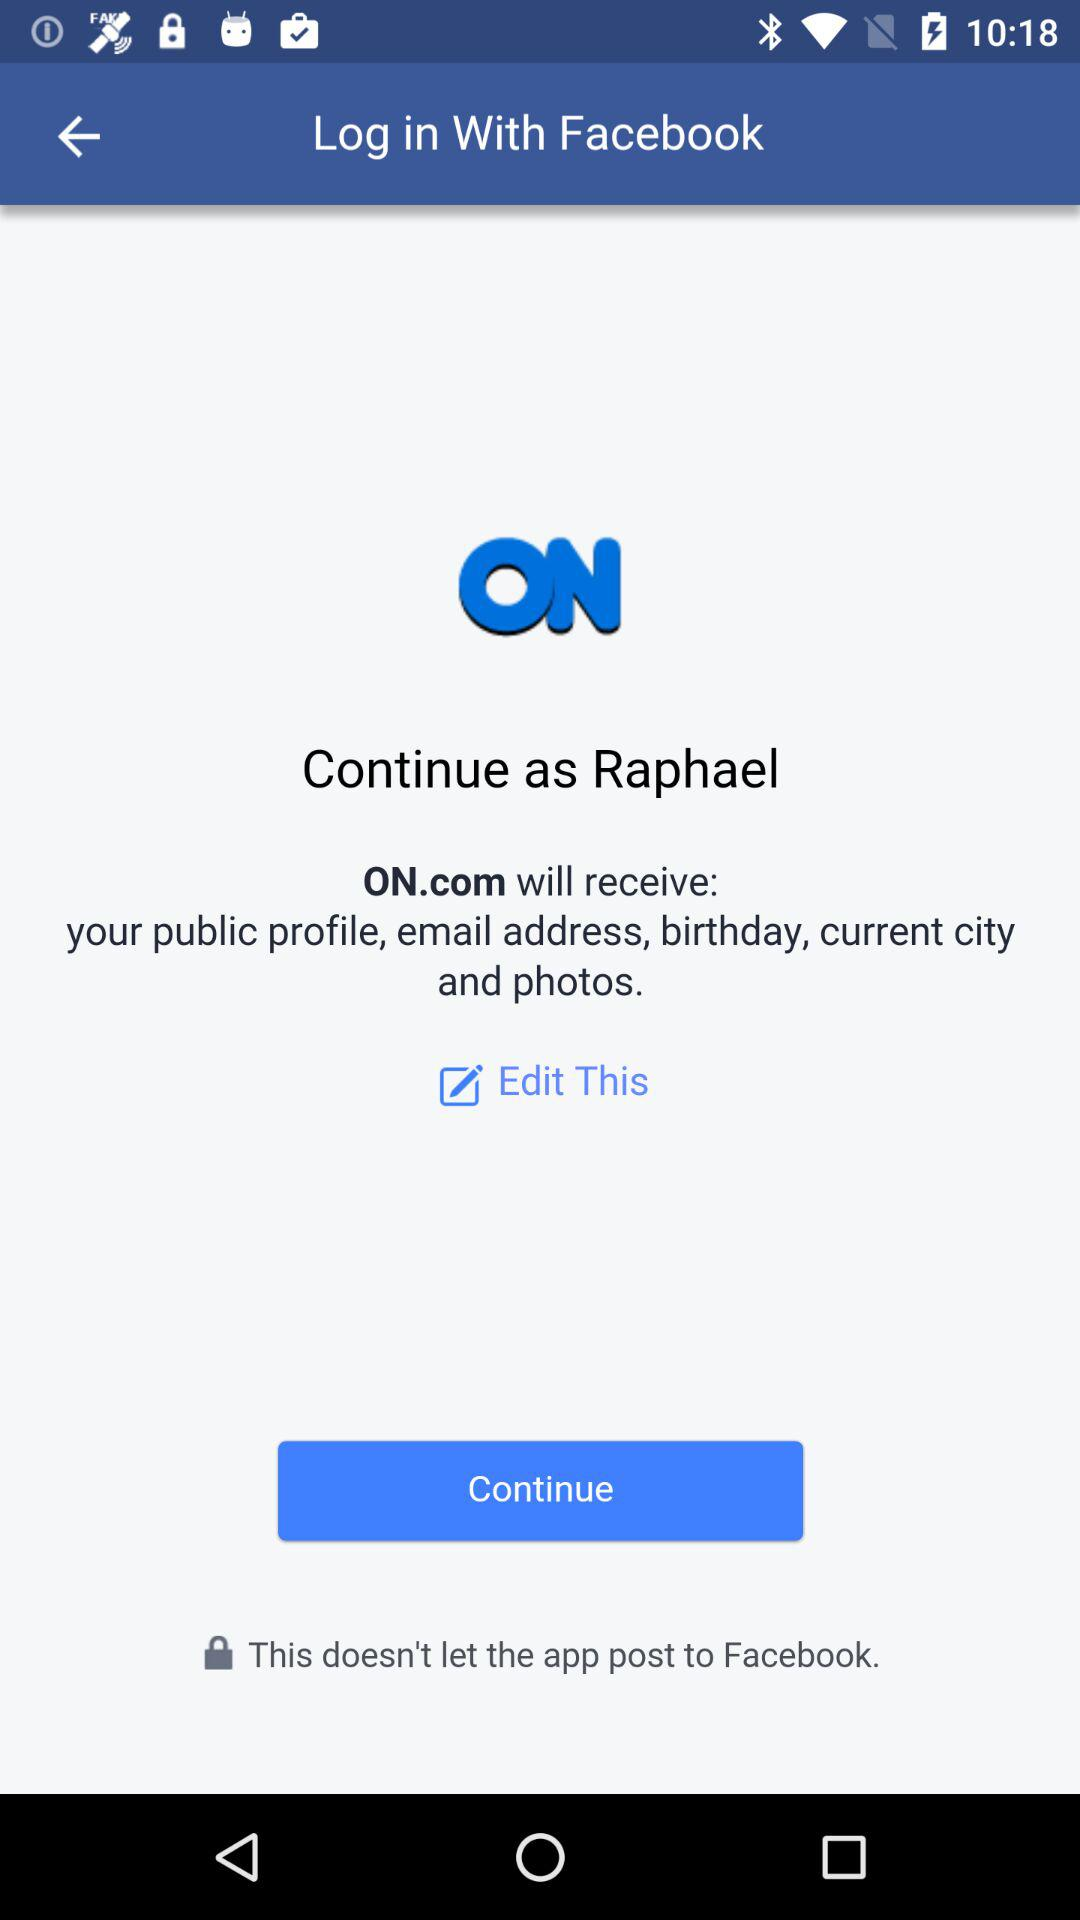What is the login name? The login name is Raphael. 